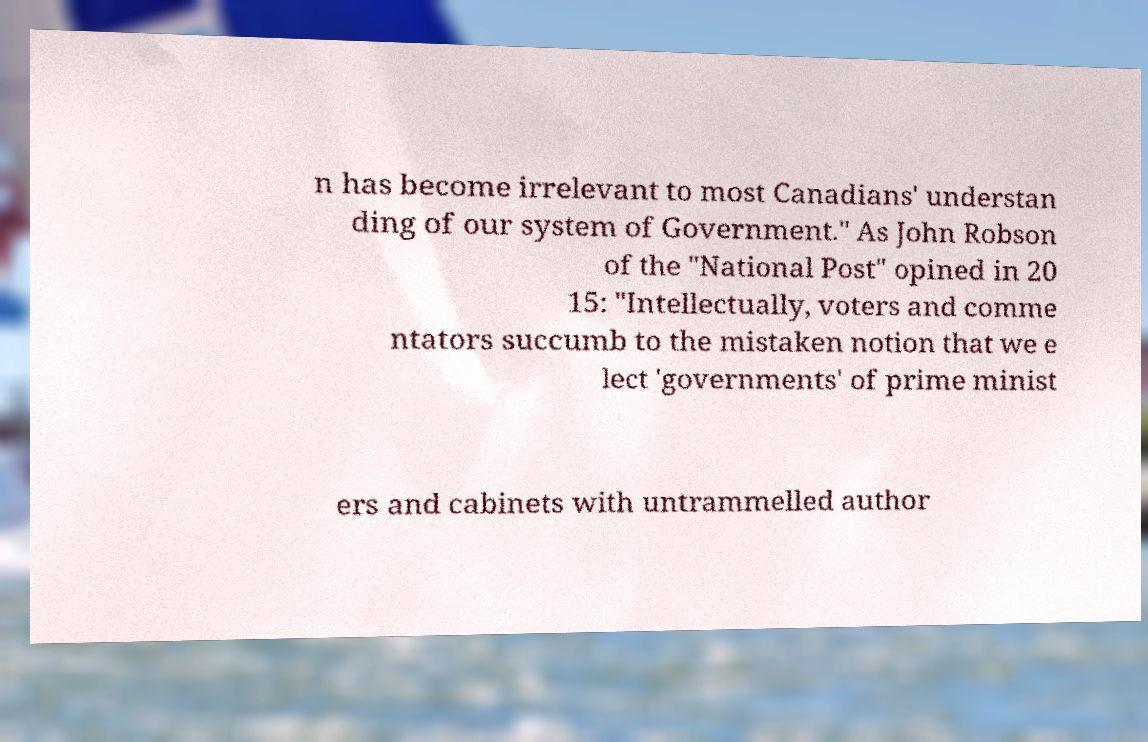Could you extract and type out the text from this image? n has become irrelevant to most Canadians' understan ding of our system of Government." As John Robson of the "National Post" opined in 20 15: "Intellectually, voters and comme ntators succumb to the mistaken notion that we e lect 'governments' of prime minist ers and cabinets with untrammelled author 